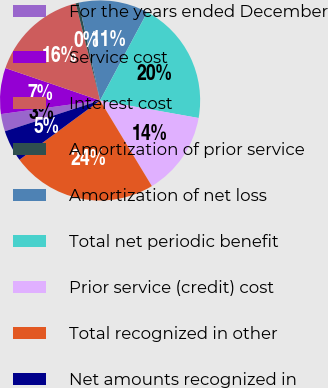Convert chart to OTSL. <chart><loc_0><loc_0><loc_500><loc_500><pie_chart><fcel>For the years ended December<fcel>Service cost<fcel>Interest cost<fcel>Amortization of prior service<fcel>Amortization of net loss<fcel>Total net periodic benefit<fcel>Prior service (credit) cost<fcel>Total recognized in other<fcel>Net amounts recognized in<nl><fcel>2.81%<fcel>7.42%<fcel>15.84%<fcel>0.5%<fcel>11.23%<fcel>19.99%<fcel>13.54%<fcel>23.56%<fcel>5.11%<nl></chart> 